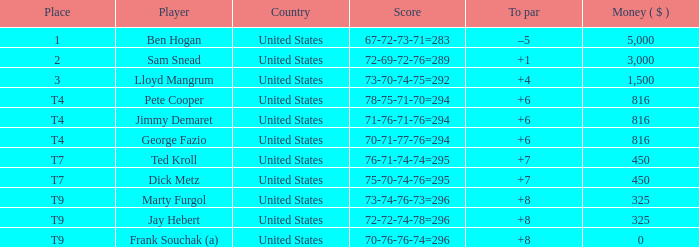What was the payment amount for the player with a score of 70-71-77-76=294? 816.0. 